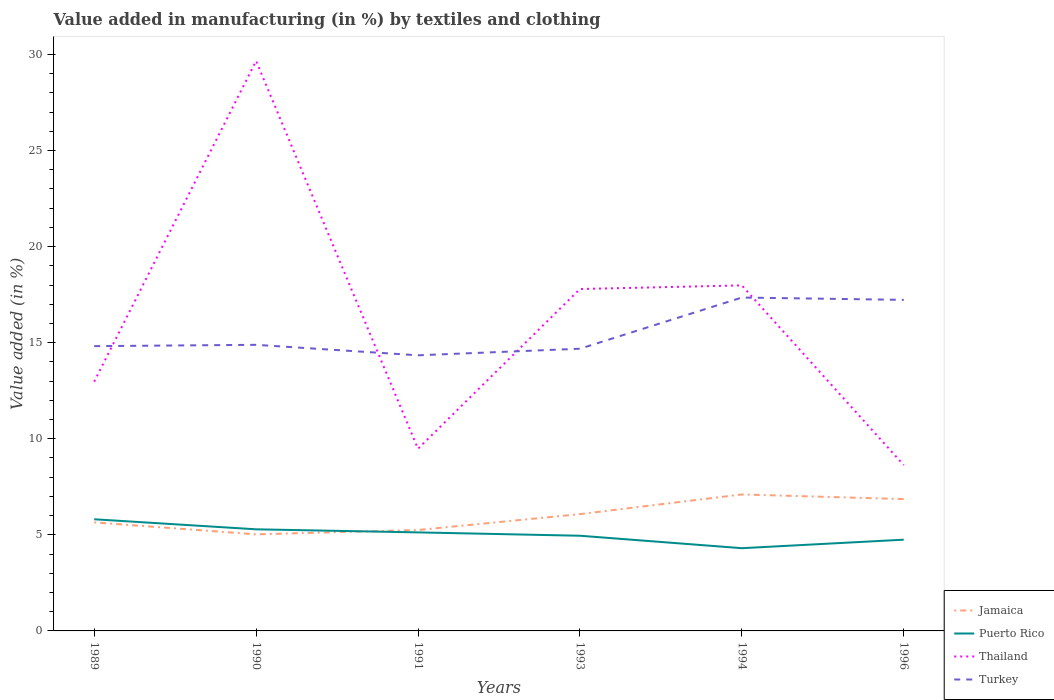How many different coloured lines are there?
Offer a very short reply. 4. Across all years, what is the maximum percentage of value added in manufacturing by textiles and clothing in Turkey?
Provide a short and direct response. 14.34. What is the total percentage of value added in manufacturing by textiles and clothing in Thailand in the graph?
Provide a short and direct response. -16.69. What is the difference between the highest and the second highest percentage of value added in manufacturing by textiles and clothing in Puerto Rico?
Your answer should be compact. 1.5. How many years are there in the graph?
Offer a terse response. 6. How are the legend labels stacked?
Provide a succinct answer. Vertical. What is the title of the graph?
Ensure brevity in your answer.  Value added in manufacturing (in %) by textiles and clothing. What is the label or title of the X-axis?
Make the answer very short. Years. What is the label or title of the Y-axis?
Your response must be concise. Value added (in %). What is the Value added (in %) of Jamaica in 1989?
Provide a short and direct response. 5.65. What is the Value added (in %) in Puerto Rico in 1989?
Offer a very short reply. 5.81. What is the Value added (in %) of Thailand in 1989?
Keep it short and to the point. 12.97. What is the Value added (in %) in Turkey in 1989?
Give a very brief answer. 14.82. What is the Value added (in %) in Jamaica in 1990?
Provide a short and direct response. 5.03. What is the Value added (in %) in Puerto Rico in 1990?
Provide a succinct answer. 5.29. What is the Value added (in %) of Thailand in 1990?
Keep it short and to the point. 29.66. What is the Value added (in %) of Turkey in 1990?
Ensure brevity in your answer.  14.89. What is the Value added (in %) in Jamaica in 1991?
Your answer should be compact. 5.25. What is the Value added (in %) in Puerto Rico in 1991?
Keep it short and to the point. 5.13. What is the Value added (in %) of Thailand in 1991?
Ensure brevity in your answer.  9.48. What is the Value added (in %) of Turkey in 1991?
Give a very brief answer. 14.34. What is the Value added (in %) in Jamaica in 1993?
Your answer should be compact. 6.08. What is the Value added (in %) of Puerto Rico in 1993?
Offer a very short reply. 4.95. What is the Value added (in %) in Thailand in 1993?
Your answer should be compact. 17.79. What is the Value added (in %) of Turkey in 1993?
Ensure brevity in your answer.  14.69. What is the Value added (in %) of Jamaica in 1994?
Offer a terse response. 7.1. What is the Value added (in %) of Puerto Rico in 1994?
Your answer should be very brief. 4.31. What is the Value added (in %) of Thailand in 1994?
Your answer should be very brief. 17.98. What is the Value added (in %) in Turkey in 1994?
Ensure brevity in your answer.  17.35. What is the Value added (in %) of Jamaica in 1996?
Your answer should be compact. 6.86. What is the Value added (in %) in Puerto Rico in 1996?
Provide a short and direct response. 4.75. What is the Value added (in %) in Thailand in 1996?
Offer a very short reply. 8.63. What is the Value added (in %) in Turkey in 1996?
Your answer should be compact. 17.23. Across all years, what is the maximum Value added (in %) in Jamaica?
Offer a terse response. 7.1. Across all years, what is the maximum Value added (in %) of Puerto Rico?
Make the answer very short. 5.81. Across all years, what is the maximum Value added (in %) in Thailand?
Offer a terse response. 29.66. Across all years, what is the maximum Value added (in %) of Turkey?
Offer a very short reply. 17.35. Across all years, what is the minimum Value added (in %) in Jamaica?
Your answer should be very brief. 5.03. Across all years, what is the minimum Value added (in %) in Puerto Rico?
Your response must be concise. 4.31. Across all years, what is the minimum Value added (in %) in Thailand?
Make the answer very short. 8.63. Across all years, what is the minimum Value added (in %) of Turkey?
Make the answer very short. 14.34. What is the total Value added (in %) in Jamaica in the graph?
Make the answer very short. 35.97. What is the total Value added (in %) of Puerto Rico in the graph?
Your response must be concise. 30.24. What is the total Value added (in %) in Thailand in the graph?
Keep it short and to the point. 96.53. What is the total Value added (in %) of Turkey in the graph?
Make the answer very short. 93.32. What is the difference between the Value added (in %) in Jamaica in 1989 and that in 1990?
Provide a short and direct response. 0.62. What is the difference between the Value added (in %) in Puerto Rico in 1989 and that in 1990?
Your answer should be very brief. 0.52. What is the difference between the Value added (in %) of Thailand in 1989 and that in 1990?
Keep it short and to the point. -16.69. What is the difference between the Value added (in %) in Turkey in 1989 and that in 1990?
Your answer should be very brief. -0.07. What is the difference between the Value added (in %) of Jamaica in 1989 and that in 1991?
Offer a very short reply. 0.4. What is the difference between the Value added (in %) of Puerto Rico in 1989 and that in 1991?
Your answer should be compact. 0.68. What is the difference between the Value added (in %) in Thailand in 1989 and that in 1991?
Offer a terse response. 3.49. What is the difference between the Value added (in %) in Turkey in 1989 and that in 1991?
Give a very brief answer. 0.48. What is the difference between the Value added (in %) in Jamaica in 1989 and that in 1993?
Your answer should be compact. -0.43. What is the difference between the Value added (in %) in Puerto Rico in 1989 and that in 1993?
Provide a succinct answer. 0.86. What is the difference between the Value added (in %) of Thailand in 1989 and that in 1993?
Your answer should be compact. -4.82. What is the difference between the Value added (in %) of Turkey in 1989 and that in 1993?
Your response must be concise. 0.14. What is the difference between the Value added (in %) of Jamaica in 1989 and that in 1994?
Ensure brevity in your answer.  -1.45. What is the difference between the Value added (in %) in Puerto Rico in 1989 and that in 1994?
Provide a short and direct response. 1.5. What is the difference between the Value added (in %) in Thailand in 1989 and that in 1994?
Provide a short and direct response. -5.01. What is the difference between the Value added (in %) of Turkey in 1989 and that in 1994?
Make the answer very short. -2.53. What is the difference between the Value added (in %) in Jamaica in 1989 and that in 1996?
Provide a short and direct response. -1.21. What is the difference between the Value added (in %) of Puerto Rico in 1989 and that in 1996?
Ensure brevity in your answer.  1.06. What is the difference between the Value added (in %) of Thailand in 1989 and that in 1996?
Provide a succinct answer. 4.34. What is the difference between the Value added (in %) in Turkey in 1989 and that in 1996?
Your response must be concise. -2.41. What is the difference between the Value added (in %) of Jamaica in 1990 and that in 1991?
Make the answer very short. -0.23. What is the difference between the Value added (in %) in Puerto Rico in 1990 and that in 1991?
Your answer should be compact. 0.16. What is the difference between the Value added (in %) of Thailand in 1990 and that in 1991?
Your answer should be compact. 20.18. What is the difference between the Value added (in %) of Turkey in 1990 and that in 1991?
Offer a terse response. 0.55. What is the difference between the Value added (in %) in Jamaica in 1990 and that in 1993?
Your answer should be compact. -1.05. What is the difference between the Value added (in %) in Puerto Rico in 1990 and that in 1993?
Make the answer very short. 0.33. What is the difference between the Value added (in %) in Thailand in 1990 and that in 1993?
Offer a very short reply. 11.87. What is the difference between the Value added (in %) in Turkey in 1990 and that in 1993?
Your answer should be compact. 0.2. What is the difference between the Value added (in %) of Jamaica in 1990 and that in 1994?
Your response must be concise. -2.08. What is the difference between the Value added (in %) in Puerto Rico in 1990 and that in 1994?
Offer a very short reply. 0.98. What is the difference between the Value added (in %) of Thailand in 1990 and that in 1994?
Make the answer very short. 11.68. What is the difference between the Value added (in %) of Turkey in 1990 and that in 1994?
Your answer should be compact. -2.46. What is the difference between the Value added (in %) of Jamaica in 1990 and that in 1996?
Ensure brevity in your answer.  -1.83. What is the difference between the Value added (in %) in Puerto Rico in 1990 and that in 1996?
Offer a very short reply. 0.54. What is the difference between the Value added (in %) of Thailand in 1990 and that in 1996?
Offer a very short reply. 21.03. What is the difference between the Value added (in %) in Turkey in 1990 and that in 1996?
Provide a succinct answer. -2.34. What is the difference between the Value added (in %) in Jamaica in 1991 and that in 1993?
Your answer should be very brief. -0.83. What is the difference between the Value added (in %) of Puerto Rico in 1991 and that in 1993?
Offer a very short reply. 0.17. What is the difference between the Value added (in %) in Thailand in 1991 and that in 1993?
Provide a succinct answer. -8.31. What is the difference between the Value added (in %) in Turkey in 1991 and that in 1993?
Keep it short and to the point. -0.34. What is the difference between the Value added (in %) of Jamaica in 1991 and that in 1994?
Give a very brief answer. -1.85. What is the difference between the Value added (in %) in Puerto Rico in 1991 and that in 1994?
Your answer should be very brief. 0.82. What is the difference between the Value added (in %) in Thailand in 1991 and that in 1994?
Ensure brevity in your answer.  -8.5. What is the difference between the Value added (in %) in Turkey in 1991 and that in 1994?
Offer a very short reply. -3.01. What is the difference between the Value added (in %) in Jamaica in 1991 and that in 1996?
Make the answer very short. -1.61. What is the difference between the Value added (in %) of Puerto Rico in 1991 and that in 1996?
Ensure brevity in your answer.  0.38. What is the difference between the Value added (in %) of Thailand in 1991 and that in 1996?
Your answer should be compact. 0.85. What is the difference between the Value added (in %) of Turkey in 1991 and that in 1996?
Offer a very short reply. -2.88. What is the difference between the Value added (in %) in Jamaica in 1993 and that in 1994?
Offer a very short reply. -1.02. What is the difference between the Value added (in %) of Puerto Rico in 1993 and that in 1994?
Your answer should be compact. 0.65. What is the difference between the Value added (in %) of Thailand in 1993 and that in 1994?
Keep it short and to the point. -0.19. What is the difference between the Value added (in %) of Turkey in 1993 and that in 1994?
Offer a terse response. -2.66. What is the difference between the Value added (in %) in Jamaica in 1993 and that in 1996?
Your answer should be very brief. -0.78. What is the difference between the Value added (in %) of Puerto Rico in 1993 and that in 1996?
Your answer should be compact. 0.21. What is the difference between the Value added (in %) in Thailand in 1993 and that in 1996?
Ensure brevity in your answer.  9.16. What is the difference between the Value added (in %) in Turkey in 1993 and that in 1996?
Your response must be concise. -2.54. What is the difference between the Value added (in %) of Jamaica in 1994 and that in 1996?
Offer a terse response. 0.24. What is the difference between the Value added (in %) of Puerto Rico in 1994 and that in 1996?
Your response must be concise. -0.44. What is the difference between the Value added (in %) of Thailand in 1994 and that in 1996?
Your response must be concise. 9.35. What is the difference between the Value added (in %) in Turkey in 1994 and that in 1996?
Offer a terse response. 0.12. What is the difference between the Value added (in %) of Jamaica in 1989 and the Value added (in %) of Puerto Rico in 1990?
Make the answer very short. 0.36. What is the difference between the Value added (in %) of Jamaica in 1989 and the Value added (in %) of Thailand in 1990?
Keep it short and to the point. -24.02. What is the difference between the Value added (in %) of Jamaica in 1989 and the Value added (in %) of Turkey in 1990?
Offer a terse response. -9.24. What is the difference between the Value added (in %) of Puerto Rico in 1989 and the Value added (in %) of Thailand in 1990?
Give a very brief answer. -23.85. What is the difference between the Value added (in %) of Puerto Rico in 1989 and the Value added (in %) of Turkey in 1990?
Offer a very short reply. -9.08. What is the difference between the Value added (in %) of Thailand in 1989 and the Value added (in %) of Turkey in 1990?
Make the answer very short. -1.92. What is the difference between the Value added (in %) in Jamaica in 1989 and the Value added (in %) in Puerto Rico in 1991?
Your response must be concise. 0.52. What is the difference between the Value added (in %) of Jamaica in 1989 and the Value added (in %) of Thailand in 1991?
Offer a terse response. -3.83. What is the difference between the Value added (in %) of Jamaica in 1989 and the Value added (in %) of Turkey in 1991?
Offer a terse response. -8.7. What is the difference between the Value added (in %) in Puerto Rico in 1989 and the Value added (in %) in Thailand in 1991?
Provide a succinct answer. -3.67. What is the difference between the Value added (in %) in Puerto Rico in 1989 and the Value added (in %) in Turkey in 1991?
Your answer should be compact. -8.53. What is the difference between the Value added (in %) of Thailand in 1989 and the Value added (in %) of Turkey in 1991?
Your answer should be compact. -1.37. What is the difference between the Value added (in %) in Jamaica in 1989 and the Value added (in %) in Puerto Rico in 1993?
Your response must be concise. 0.69. What is the difference between the Value added (in %) in Jamaica in 1989 and the Value added (in %) in Thailand in 1993?
Ensure brevity in your answer.  -12.15. What is the difference between the Value added (in %) in Jamaica in 1989 and the Value added (in %) in Turkey in 1993?
Your response must be concise. -9.04. What is the difference between the Value added (in %) of Puerto Rico in 1989 and the Value added (in %) of Thailand in 1993?
Offer a very short reply. -11.98. What is the difference between the Value added (in %) of Puerto Rico in 1989 and the Value added (in %) of Turkey in 1993?
Your answer should be very brief. -8.88. What is the difference between the Value added (in %) in Thailand in 1989 and the Value added (in %) in Turkey in 1993?
Offer a terse response. -1.71. What is the difference between the Value added (in %) in Jamaica in 1989 and the Value added (in %) in Puerto Rico in 1994?
Provide a succinct answer. 1.34. What is the difference between the Value added (in %) of Jamaica in 1989 and the Value added (in %) of Thailand in 1994?
Provide a succinct answer. -12.33. What is the difference between the Value added (in %) of Jamaica in 1989 and the Value added (in %) of Turkey in 1994?
Make the answer very short. -11.7. What is the difference between the Value added (in %) of Puerto Rico in 1989 and the Value added (in %) of Thailand in 1994?
Your answer should be compact. -12.17. What is the difference between the Value added (in %) in Puerto Rico in 1989 and the Value added (in %) in Turkey in 1994?
Your response must be concise. -11.54. What is the difference between the Value added (in %) of Thailand in 1989 and the Value added (in %) of Turkey in 1994?
Offer a terse response. -4.38. What is the difference between the Value added (in %) in Jamaica in 1989 and the Value added (in %) in Puerto Rico in 1996?
Provide a succinct answer. 0.9. What is the difference between the Value added (in %) of Jamaica in 1989 and the Value added (in %) of Thailand in 1996?
Your answer should be compact. -2.98. What is the difference between the Value added (in %) in Jamaica in 1989 and the Value added (in %) in Turkey in 1996?
Your response must be concise. -11.58. What is the difference between the Value added (in %) in Puerto Rico in 1989 and the Value added (in %) in Thailand in 1996?
Your answer should be very brief. -2.82. What is the difference between the Value added (in %) in Puerto Rico in 1989 and the Value added (in %) in Turkey in 1996?
Your answer should be very brief. -11.42. What is the difference between the Value added (in %) in Thailand in 1989 and the Value added (in %) in Turkey in 1996?
Your answer should be very brief. -4.25. What is the difference between the Value added (in %) in Jamaica in 1990 and the Value added (in %) in Puerto Rico in 1991?
Provide a succinct answer. -0.1. What is the difference between the Value added (in %) of Jamaica in 1990 and the Value added (in %) of Thailand in 1991?
Your answer should be compact. -4.46. What is the difference between the Value added (in %) in Jamaica in 1990 and the Value added (in %) in Turkey in 1991?
Offer a very short reply. -9.32. What is the difference between the Value added (in %) of Puerto Rico in 1990 and the Value added (in %) of Thailand in 1991?
Provide a short and direct response. -4.19. What is the difference between the Value added (in %) in Puerto Rico in 1990 and the Value added (in %) in Turkey in 1991?
Offer a very short reply. -9.06. What is the difference between the Value added (in %) of Thailand in 1990 and the Value added (in %) of Turkey in 1991?
Ensure brevity in your answer.  15.32. What is the difference between the Value added (in %) in Jamaica in 1990 and the Value added (in %) in Puerto Rico in 1993?
Your answer should be very brief. 0.07. What is the difference between the Value added (in %) in Jamaica in 1990 and the Value added (in %) in Thailand in 1993?
Give a very brief answer. -12.77. What is the difference between the Value added (in %) in Jamaica in 1990 and the Value added (in %) in Turkey in 1993?
Your response must be concise. -9.66. What is the difference between the Value added (in %) in Puerto Rico in 1990 and the Value added (in %) in Thailand in 1993?
Your answer should be compact. -12.51. What is the difference between the Value added (in %) in Puerto Rico in 1990 and the Value added (in %) in Turkey in 1993?
Your answer should be compact. -9.4. What is the difference between the Value added (in %) of Thailand in 1990 and the Value added (in %) of Turkey in 1993?
Provide a succinct answer. 14.98. What is the difference between the Value added (in %) in Jamaica in 1990 and the Value added (in %) in Puerto Rico in 1994?
Offer a terse response. 0.72. What is the difference between the Value added (in %) of Jamaica in 1990 and the Value added (in %) of Thailand in 1994?
Make the answer very short. -12.96. What is the difference between the Value added (in %) of Jamaica in 1990 and the Value added (in %) of Turkey in 1994?
Ensure brevity in your answer.  -12.32. What is the difference between the Value added (in %) in Puerto Rico in 1990 and the Value added (in %) in Thailand in 1994?
Your answer should be very brief. -12.7. What is the difference between the Value added (in %) of Puerto Rico in 1990 and the Value added (in %) of Turkey in 1994?
Ensure brevity in your answer.  -12.06. What is the difference between the Value added (in %) of Thailand in 1990 and the Value added (in %) of Turkey in 1994?
Provide a short and direct response. 12.31. What is the difference between the Value added (in %) in Jamaica in 1990 and the Value added (in %) in Puerto Rico in 1996?
Give a very brief answer. 0.28. What is the difference between the Value added (in %) in Jamaica in 1990 and the Value added (in %) in Thailand in 1996?
Ensure brevity in your answer.  -3.61. What is the difference between the Value added (in %) of Jamaica in 1990 and the Value added (in %) of Turkey in 1996?
Make the answer very short. -12.2. What is the difference between the Value added (in %) in Puerto Rico in 1990 and the Value added (in %) in Thailand in 1996?
Your answer should be compact. -3.34. What is the difference between the Value added (in %) in Puerto Rico in 1990 and the Value added (in %) in Turkey in 1996?
Keep it short and to the point. -11.94. What is the difference between the Value added (in %) of Thailand in 1990 and the Value added (in %) of Turkey in 1996?
Ensure brevity in your answer.  12.43. What is the difference between the Value added (in %) of Jamaica in 1991 and the Value added (in %) of Puerto Rico in 1993?
Your answer should be compact. 0.3. What is the difference between the Value added (in %) of Jamaica in 1991 and the Value added (in %) of Thailand in 1993?
Provide a succinct answer. -12.54. What is the difference between the Value added (in %) of Jamaica in 1991 and the Value added (in %) of Turkey in 1993?
Ensure brevity in your answer.  -9.43. What is the difference between the Value added (in %) of Puerto Rico in 1991 and the Value added (in %) of Thailand in 1993?
Provide a short and direct response. -12.67. What is the difference between the Value added (in %) in Puerto Rico in 1991 and the Value added (in %) in Turkey in 1993?
Offer a very short reply. -9.56. What is the difference between the Value added (in %) of Thailand in 1991 and the Value added (in %) of Turkey in 1993?
Your answer should be compact. -5.2. What is the difference between the Value added (in %) in Jamaica in 1991 and the Value added (in %) in Puerto Rico in 1994?
Make the answer very short. 0.95. What is the difference between the Value added (in %) of Jamaica in 1991 and the Value added (in %) of Thailand in 1994?
Offer a terse response. -12.73. What is the difference between the Value added (in %) in Jamaica in 1991 and the Value added (in %) in Turkey in 1994?
Keep it short and to the point. -12.1. What is the difference between the Value added (in %) in Puerto Rico in 1991 and the Value added (in %) in Thailand in 1994?
Provide a short and direct response. -12.85. What is the difference between the Value added (in %) of Puerto Rico in 1991 and the Value added (in %) of Turkey in 1994?
Provide a succinct answer. -12.22. What is the difference between the Value added (in %) in Thailand in 1991 and the Value added (in %) in Turkey in 1994?
Keep it short and to the point. -7.87. What is the difference between the Value added (in %) of Jamaica in 1991 and the Value added (in %) of Puerto Rico in 1996?
Provide a short and direct response. 0.5. What is the difference between the Value added (in %) in Jamaica in 1991 and the Value added (in %) in Thailand in 1996?
Your answer should be compact. -3.38. What is the difference between the Value added (in %) of Jamaica in 1991 and the Value added (in %) of Turkey in 1996?
Keep it short and to the point. -11.98. What is the difference between the Value added (in %) in Puerto Rico in 1991 and the Value added (in %) in Thailand in 1996?
Keep it short and to the point. -3.5. What is the difference between the Value added (in %) of Puerto Rico in 1991 and the Value added (in %) of Turkey in 1996?
Provide a short and direct response. -12.1. What is the difference between the Value added (in %) of Thailand in 1991 and the Value added (in %) of Turkey in 1996?
Keep it short and to the point. -7.75. What is the difference between the Value added (in %) of Jamaica in 1993 and the Value added (in %) of Puerto Rico in 1994?
Give a very brief answer. 1.77. What is the difference between the Value added (in %) in Jamaica in 1993 and the Value added (in %) in Thailand in 1994?
Make the answer very short. -11.9. What is the difference between the Value added (in %) in Jamaica in 1993 and the Value added (in %) in Turkey in 1994?
Your response must be concise. -11.27. What is the difference between the Value added (in %) in Puerto Rico in 1993 and the Value added (in %) in Thailand in 1994?
Your response must be concise. -13.03. What is the difference between the Value added (in %) in Puerto Rico in 1993 and the Value added (in %) in Turkey in 1994?
Keep it short and to the point. -12.4. What is the difference between the Value added (in %) of Thailand in 1993 and the Value added (in %) of Turkey in 1994?
Offer a very short reply. 0.44. What is the difference between the Value added (in %) in Jamaica in 1993 and the Value added (in %) in Puerto Rico in 1996?
Your response must be concise. 1.33. What is the difference between the Value added (in %) in Jamaica in 1993 and the Value added (in %) in Thailand in 1996?
Offer a terse response. -2.55. What is the difference between the Value added (in %) in Jamaica in 1993 and the Value added (in %) in Turkey in 1996?
Give a very brief answer. -11.15. What is the difference between the Value added (in %) of Puerto Rico in 1993 and the Value added (in %) of Thailand in 1996?
Provide a short and direct response. -3.68. What is the difference between the Value added (in %) of Puerto Rico in 1993 and the Value added (in %) of Turkey in 1996?
Offer a terse response. -12.28. What is the difference between the Value added (in %) of Thailand in 1993 and the Value added (in %) of Turkey in 1996?
Offer a very short reply. 0.56. What is the difference between the Value added (in %) in Jamaica in 1994 and the Value added (in %) in Puerto Rico in 1996?
Offer a very short reply. 2.35. What is the difference between the Value added (in %) of Jamaica in 1994 and the Value added (in %) of Thailand in 1996?
Provide a short and direct response. -1.53. What is the difference between the Value added (in %) of Jamaica in 1994 and the Value added (in %) of Turkey in 1996?
Your answer should be compact. -10.13. What is the difference between the Value added (in %) in Puerto Rico in 1994 and the Value added (in %) in Thailand in 1996?
Your answer should be very brief. -4.33. What is the difference between the Value added (in %) of Puerto Rico in 1994 and the Value added (in %) of Turkey in 1996?
Offer a terse response. -12.92. What is the difference between the Value added (in %) in Thailand in 1994 and the Value added (in %) in Turkey in 1996?
Your response must be concise. 0.75. What is the average Value added (in %) of Jamaica per year?
Your answer should be very brief. 5.99. What is the average Value added (in %) of Puerto Rico per year?
Your answer should be compact. 5.04. What is the average Value added (in %) of Thailand per year?
Provide a short and direct response. 16.09. What is the average Value added (in %) of Turkey per year?
Your answer should be very brief. 15.55. In the year 1989, what is the difference between the Value added (in %) in Jamaica and Value added (in %) in Puerto Rico?
Your answer should be compact. -0.16. In the year 1989, what is the difference between the Value added (in %) of Jamaica and Value added (in %) of Thailand?
Offer a terse response. -7.33. In the year 1989, what is the difference between the Value added (in %) in Jamaica and Value added (in %) in Turkey?
Provide a short and direct response. -9.17. In the year 1989, what is the difference between the Value added (in %) of Puerto Rico and Value added (in %) of Thailand?
Your answer should be very brief. -7.16. In the year 1989, what is the difference between the Value added (in %) in Puerto Rico and Value added (in %) in Turkey?
Your answer should be compact. -9.01. In the year 1989, what is the difference between the Value added (in %) of Thailand and Value added (in %) of Turkey?
Offer a very short reply. -1.85. In the year 1990, what is the difference between the Value added (in %) of Jamaica and Value added (in %) of Puerto Rico?
Give a very brief answer. -0.26. In the year 1990, what is the difference between the Value added (in %) in Jamaica and Value added (in %) in Thailand?
Offer a terse response. -24.64. In the year 1990, what is the difference between the Value added (in %) of Jamaica and Value added (in %) of Turkey?
Your answer should be very brief. -9.86. In the year 1990, what is the difference between the Value added (in %) of Puerto Rico and Value added (in %) of Thailand?
Make the answer very short. -24.38. In the year 1990, what is the difference between the Value added (in %) in Puerto Rico and Value added (in %) in Turkey?
Make the answer very short. -9.6. In the year 1990, what is the difference between the Value added (in %) in Thailand and Value added (in %) in Turkey?
Ensure brevity in your answer.  14.77. In the year 1991, what is the difference between the Value added (in %) in Jamaica and Value added (in %) in Puerto Rico?
Provide a short and direct response. 0.12. In the year 1991, what is the difference between the Value added (in %) in Jamaica and Value added (in %) in Thailand?
Provide a succinct answer. -4.23. In the year 1991, what is the difference between the Value added (in %) in Jamaica and Value added (in %) in Turkey?
Your answer should be compact. -9.09. In the year 1991, what is the difference between the Value added (in %) of Puerto Rico and Value added (in %) of Thailand?
Make the answer very short. -4.35. In the year 1991, what is the difference between the Value added (in %) of Puerto Rico and Value added (in %) of Turkey?
Your response must be concise. -9.22. In the year 1991, what is the difference between the Value added (in %) of Thailand and Value added (in %) of Turkey?
Ensure brevity in your answer.  -4.86. In the year 1993, what is the difference between the Value added (in %) of Jamaica and Value added (in %) of Puerto Rico?
Your response must be concise. 1.13. In the year 1993, what is the difference between the Value added (in %) of Jamaica and Value added (in %) of Thailand?
Your response must be concise. -11.71. In the year 1993, what is the difference between the Value added (in %) of Jamaica and Value added (in %) of Turkey?
Keep it short and to the point. -8.61. In the year 1993, what is the difference between the Value added (in %) of Puerto Rico and Value added (in %) of Thailand?
Provide a succinct answer. -12.84. In the year 1993, what is the difference between the Value added (in %) in Puerto Rico and Value added (in %) in Turkey?
Ensure brevity in your answer.  -9.73. In the year 1993, what is the difference between the Value added (in %) of Thailand and Value added (in %) of Turkey?
Your response must be concise. 3.11. In the year 1994, what is the difference between the Value added (in %) of Jamaica and Value added (in %) of Puerto Rico?
Give a very brief answer. 2.8. In the year 1994, what is the difference between the Value added (in %) of Jamaica and Value added (in %) of Thailand?
Provide a succinct answer. -10.88. In the year 1994, what is the difference between the Value added (in %) of Jamaica and Value added (in %) of Turkey?
Give a very brief answer. -10.25. In the year 1994, what is the difference between the Value added (in %) in Puerto Rico and Value added (in %) in Thailand?
Your response must be concise. -13.68. In the year 1994, what is the difference between the Value added (in %) in Puerto Rico and Value added (in %) in Turkey?
Your answer should be very brief. -13.04. In the year 1994, what is the difference between the Value added (in %) in Thailand and Value added (in %) in Turkey?
Keep it short and to the point. 0.63. In the year 1996, what is the difference between the Value added (in %) of Jamaica and Value added (in %) of Puerto Rico?
Give a very brief answer. 2.11. In the year 1996, what is the difference between the Value added (in %) of Jamaica and Value added (in %) of Thailand?
Keep it short and to the point. -1.77. In the year 1996, what is the difference between the Value added (in %) in Jamaica and Value added (in %) in Turkey?
Provide a succinct answer. -10.37. In the year 1996, what is the difference between the Value added (in %) of Puerto Rico and Value added (in %) of Thailand?
Your answer should be compact. -3.88. In the year 1996, what is the difference between the Value added (in %) of Puerto Rico and Value added (in %) of Turkey?
Offer a very short reply. -12.48. In the year 1996, what is the difference between the Value added (in %) of Thailand and Value added (in %) of Turkey?
Your answer should be compact. -8.6. What is the ratio of the Value added (in %) of Jamaica in 1989 to that in 1990?
Ensure brevity in your answer.  1.12. What is the ratio of the Value added (in %) in Puerto Rico in 1989 to that in 1990?
Ensure brevity in your answer.  1.1. What is the ratio of the Value added (in %) in Thailand in 1989 to that in 1990?
Ensure brevity in your answer.  0.44. What is the ratio of the Value added (in %) of Turkey in 1989 to that in 1990?
Provide a short and direct response. 1. What is the ratio of the Value added (in %) in Jamaica in 1989 to that in 1991?
Offer a terse response. 1.08. What is the ratio of the Value added (in %) of Puerto Rico in 1989 to that in 1991?
Make the answer very short. 1.13. What is the ratio of the Value added (in %) of Thailand in 1989 to that in 1991?
Give a very brief answer. 1.37. What is the ratio of the Value added (in %) of Jamaica in 1989 to that in 1993?
Make the answer very short. 0.93. What is the ratio of the Value added (in %) of Puerto Rico in 1989 to that in 1993?
Provide a short and direct response. 1.17. What is the ratio of the Value added (in %) in Thailand in 1989 to that in 1993?
Offer a terse response. 0.73. What is the ratio of the Value added (in %) in Turkey in 1989 to that in 1993?
Keep it short and to the point. 1.01. What is the ratio of the Value added (in %) of Jamaica in 1989 to that in 1994?
Ensure brevity in your answer.  0.8. What is the ratio of the Value added (in %) in Puerto Rico in 1989 to that in 1994?
Your response must be concise. 1.35. What is the ratio of the Value added (in %) in Thailand in 1989 to that in 1994?
Make the answer very short. 0.72. What is the ratio of the Value added (in %) in Turkey in 1989 to that in 1994?
Keep it short and to the point. 0.85. What is the ratio of the Value added (in %) in Jamaica in 1989 to that in 1996?
Provide a succinct answer. 0.82. What is the ratio of the Value added (in %) of Puerto Rico in 1989 to that in 1996?
Ensure brevity in your answer.  1.22. What is the ratio of the Value added (in %) of Thailand in 1989 to that in 1996?
Provide a succinct answer. 1.5. What is the ratio of the Value added (in %) in Turkey in 1989 to that in 1996?
Give a very brief answer. 0.86. What is the ratio of the Value added (in %) in Jamaica in 1990 to that in 1991?
Keep it short and to the point. 0.96. What is the ratio of the Value added (in %) of Puerto Rico in 1990 to that in 1991?
Your response must be concise. 1.03. What is the ratio of the Value added (in %) in Thailand in 1990 to that in 1991?
Offer a very short reply. 3.13. What is the ratio of the Value added (in %) of Turkey in 1990 to that in 1991?
Your answer should be very brief. 1.04. What is the ratio of the Value added (in %) of Jamaica in 1990 to that in 1993?
Provide a succinct answer. 0.83. What is the ratio of the Value added (in %) of Puerto Rico in 1990 to that in 1993?
Give a very brief answer. 1.07. What is the ratio of the Value added (in %) in Thailand in 1990 to that in 1993?
Offer a terse response. 1.67. What is the ratio of the Value added (in %) of Turkey in 1990 to that in 1993?
Offer a terse response. 1.01. What is the ratio of the Value added (in %) in Jamaica in 1990 to that in 1994?
Provide a succinct answer. 0.71. What is the ratio of the Value added (in %) in Puerto Rico in 1990 to that in 1994?
Give a very brief answer. 1.23. What is the ratio of the Value added (in %) in Thailand in 1990 to that in 1994?
Make the answer very short. 1.65. What is the ratio of the Value added (in %) of Turkey in 1990 to that in 1994?
Ensure brevity in your answer.  0.86. What is the ratio of the Value added (in %) of Jamaica in 1990 to that in 1996?
Offer a very short reply. 0.73. What is the ratio of the Value added (in %) in Puerto Rico in 1990 to that in 1996?
Ensure brevity in your answer.  1.11. What is the ratio of the Value added (in %) in Thailand in 1990 to that in 1996?
Your response must be concise. 3.44. What is the ratio of the Value added (in %) of Turkey in 1990 to that in 1996?
Make the answer very short. 0.86. What is the ratio of the Value added (in %) of Jamaica in 1991 to that in 1993?
Your answer should be compact. 0.86. What is the ratio of the Value added (in %) in Puerto Rico in 1991 to that in 1993?
Keep it short and to the point. 1.04. What is the ratio of the Value added (in %) in Thailand in 1991 to that in 1993?
Ensure brevity in your answer.  0.53. What is the ratio of the Value added (in %) of Turkey in 1991 to that in 1993?
Give a very brief answer. 0.98. What is the ratio of the Value added (in %) of Jamaica in 1991 to that in 1994?
Ensure brevity in your answer.  0.74. What is the ratio of the Value added (in %) of Puerto Rico in 1991 to that in 1994?
Offer a terse response. 1.19. What is the ratio of the Value added (in %) in Thailand in 1991 to that in 1994?
Give a very brief answer. 0.53. What is the ratio of the Value added (in %) of Turkey in 1991 to that in 1994?
Provide a succinct answer. 0.83. What is the ratio of the Value added (in %) of Jamaica in 1991 to that in 1996?
Offer a very short reply. 0.77. What is the ratio of the Value added (in %) of Puerto Rico in 1991 to that in 1996?
Keep it short and to the point. 1.08. What is the ratio of the Value added (in %) in Thailand in 1991 to that in 1996?
Ensure brevity in your answer.  1.1. What is the ratio of the Value added (in %) in Turkey in 1991 to that in 1996?
Your response must be concise. 0.83. What is the ratio of the Value added (in %) in Jamaica in 1993 to that in 1994?
Offer a very short reply. 0.86. What is the ratio of the Value added (in %) in Puerto Rico in 1993 to that in 1994?
Ensure brevity in your answer.  1.15. What is the ratio of the Value added (in %) of Turkey in 1993 to that in 1994?
Offer a very short reply. 0.85. What is the ratio of the Value added (in %) of Jamaica in 1993 to that in 1996?
Offer a terse response. 0.89. What is the ratio of the Value added (in %) in Puerto Rico in 1993 to that in 1996?
Your response must be concise. 1.04. What is the ratio of the Value added (in %) in Thailand in 1993 to that in 1996?
Ensure brevity in your answer.  2.06. What is the ratio of the Value added (in %) of Turkey in 1993 to that in 1996?
Provide a short and direct response. 0.85. What is the ratio of the Value added (in %) in Jamaica in 1994 to that in 1996?
Give a very brief answer. 1.04. What is the ratio of the Value added (in %) in Puerto Rico in 1994 to that in 1996?
Make the answer very short. 0.91. What is the ratio of the Value added (in %) in Thailand in 1994 to that in 1996?
Your answer should be very brief. 2.08. What is the ratio of the Value added (in %) in Turkey in 1994 to that in 1996?
Provide a short and direct response. 1.01. What is the difference between the highest and the second highest Value added (in %) of Jamaica?
Offer a terse response. 0.24. What is the difference between the highest and the second highest Value added (in %) of Puerto Rico?
Offer a very short reply. 0.52. What is the difference between the highest and the second highest Value added (in %) of Thailand?
Make the answer very short. 11.68. What is the difference between the highest and the second highest Value added (in %) of Turkey?
Ensure brevity in your answer.  0.12. What is the difference between the highest and the lowest Value added (in %) of Jamaica?
Make the answer very short. 2.08. What is the difference between the highest and the lowest Value added (in %) of Puerto Rico?
Provide a short and direct response. 1.5. What is the difference between the highest and the lowest Value added (in %) in Thailand?
Your response must be concise. 21.03. What is the difference between the highest and the lowest Value added (in %) of Turkey?
Your answer should be compact. 3.01. 